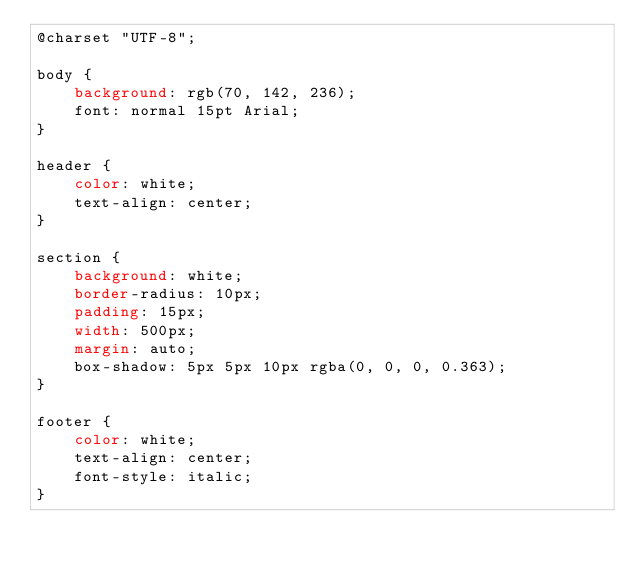<code> <loc_0><loc_0><loc_500><loc_500><_CSS_>@charset "UTF-8";

body {
    background: rgb(70, 142, 236);
    font: normal 15pt Arial;
}

header {
    color: white;
    text-align: center;
}

section {
    background: white;
    border-radius: 10px;
    padding: 15px;
    width: 500px;
    margin: auto;
    box-shadow: 5px 5px 10px rgba(0, 0, 0, 0.363);
}

footer {
    color: white;
    text-align: center;
    font-style: italic;
}</code> 